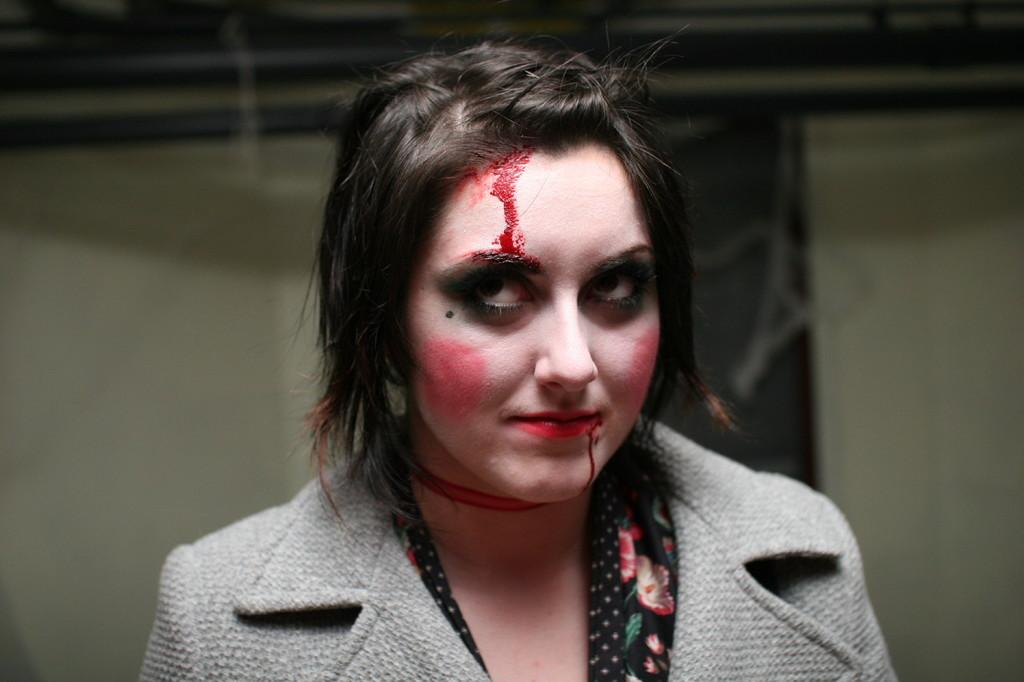Who is present in the image? There is a woman in the image. What is the woman's facial expression? The woman is smiling. Can you describe any injuries or marks on the woman's face? There is blood on the woman's face. What can be seen in the background of the image? There are objects and walls visible in the background of the image. What type of thread is being used to sew the deer's wound in the image? There is no deer or thread present in the image; it features a woman with blood on her face. 